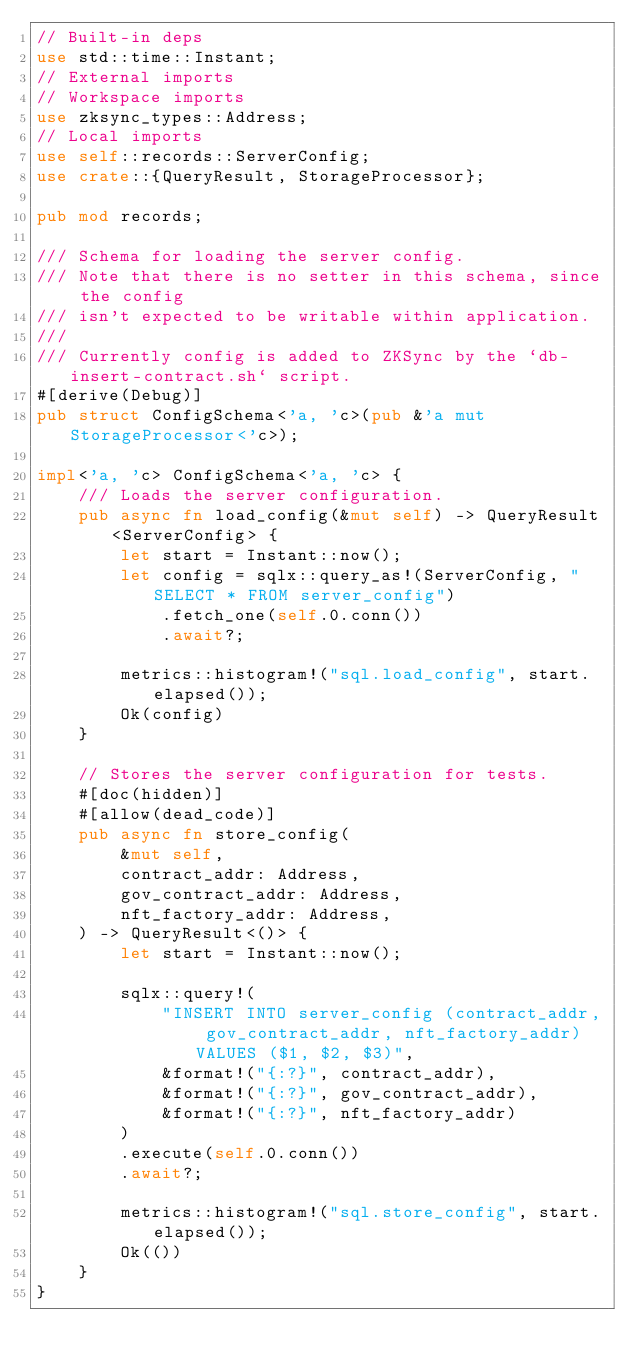<code> <loc_0><loc_0><loc_500><loc_500><_Rust_>// Built-in deps
use std::time::Instant;
// External imports
// Workspace imports
use zksync_types::Address;
// Local imports
use self::records::ServerConfig;
use crate::{QueryResult, StorageProcessor};

pub mod records;

/// Schema for loading the server config.
/// Note that there is no setter in this schema, since the config
/// isn't expected to be writable within application.
///
/// Currently config is added to ZKSync by the `db-insert-contract.sh` script.
#[derive(Debug)]
pub struct ConfigSchema<'a, 'c>(pub &'a mut StorageProcessor<'c>);

impl<'a, 'c> ConfigSchema<'a, 'c> {
    /// Loads the server configuration.
    pub async fn load_config(&mut self) -> QueryResult<ServerConfig> {
        let start = Instant::now();
        let config = sqlx::query_as!(ServerConfig, "SELECT * FROM server_config")
            .fetch_one(self.0.conn())
            .await?;

        metrics::histogram!("sql.load_config", start.elapsed());
        Ok(config)
    }

    // Stores the server configuration for tests.
    #[doc(hidden)]
    #[allow(dead_code)]
    pub async fn store_config(
        &mut self,
        contract_addr: Address,
        gov_contract_addr: Address,
        nft_factory_addr: Address,
    ) -> QueryResult<()> {
        let start = Instant::now();

        sqlx::query!(
            "INSERT INTO server_config (contract_addr, gov_contract_addr, nft_factory_addr) VALUES ($1, $2, $3)",
            &format!("{:?}", contract_addr),
            &format!("{:?}", gov_contract_addr),
            &format!("{:?}", nft_factory_addr)
        )
        .execute(self.0.conn())
        .await?;

        metrics::histogram!("sql.store_config", start.elapsed());
        Ok(())
    }
}
</code> 